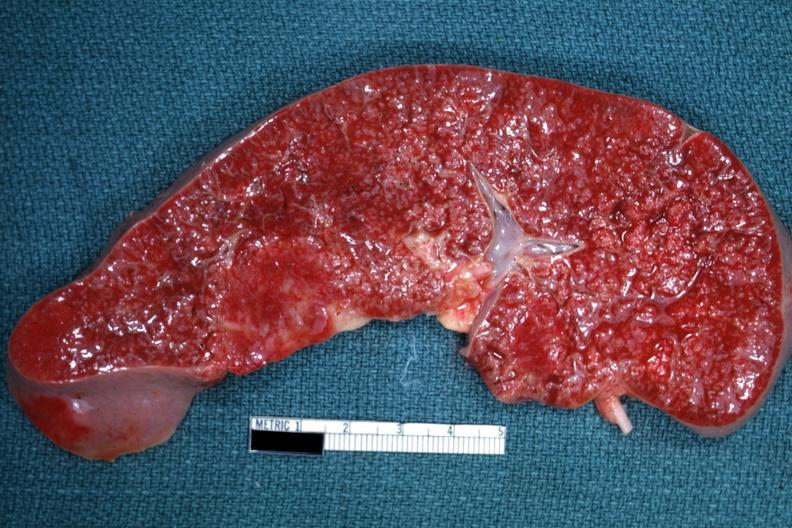s focal hemorrhages diagnosed as reticulum cell sarcoma?
Answer the question using a single word or phrase. No 